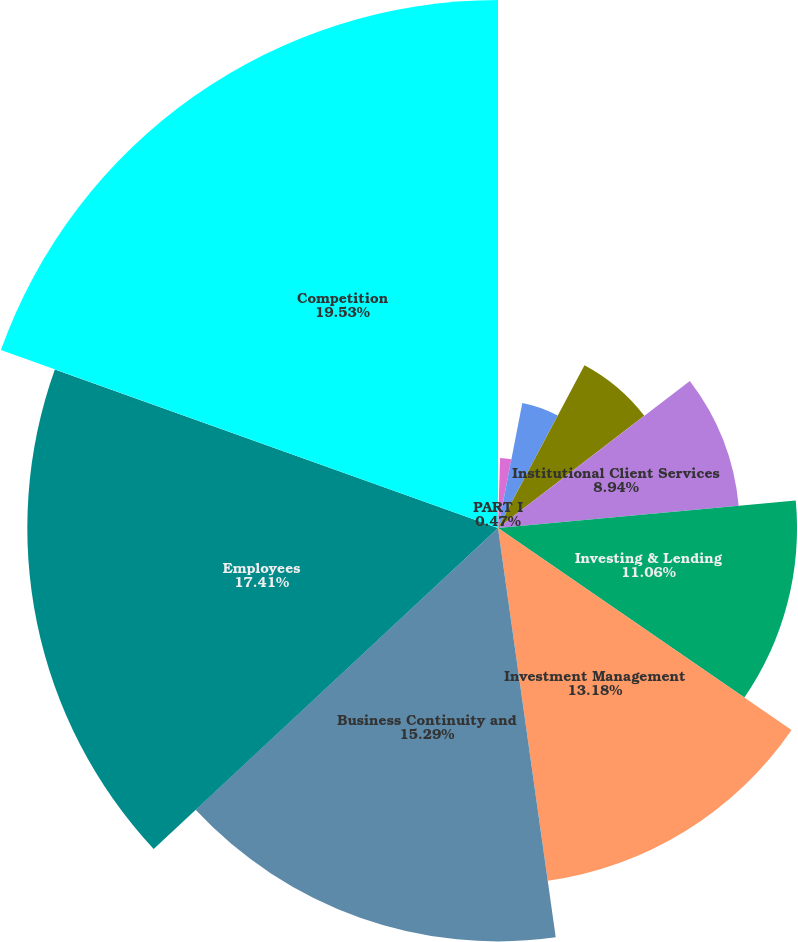<chart> <loc_0><loc_0><loc_500><loc_500><pie_chart><fcel>PART I<fcel>Business<fcel>Introduction<fcel>Investment Banking<fcel>Institutional Client Services<fcel>Investing & Lending<fcel>Investment Management<fcel>Business Continuity and<fcel>Employees<fcel>Competition<nl><fcel>0.47%<fcel>2.59%<fcel>4.71%<fcel>6.82%<fcel>8.94%<fcel>11.06%<fcel>13.18%<fcel>15.29%<fcel>17.41%<fcel>19.53%<nl></chart> 